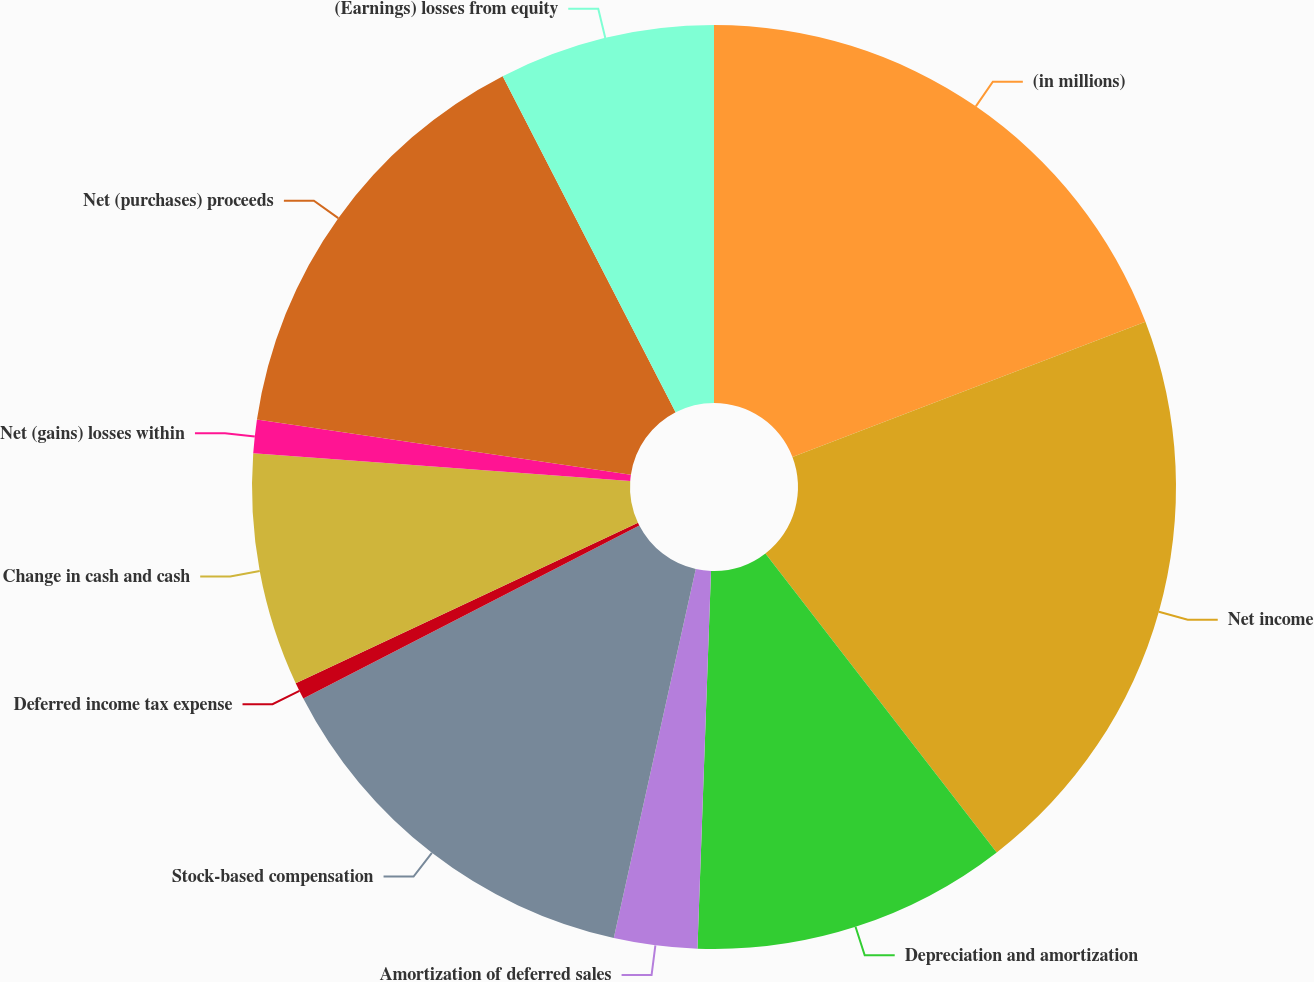Convert chart. <chart><loc_0><loc_0><loc_500><loc_500><pie_chart><fcel>(in millions)<fcel>Net income<fcel>Depreciation and amortization<fcel>Amortization of deferred sales<fcel>Stock-based compensation<fcel>Deferred income tax expense<fcel>Change in cash and cash<fcel>Net (gains) losses within<fcel>Net (purchases) proceeds<fcel>(Earnings) losses from equity<nl><fcel>19.18%<fcel>20.34%<fcel>11.05%<fcel>2.91%<fcel>13.95%<fcel>0.59%<fcel>8.14%<fcel>1.17%<fcel>15.11%<fcel>7.56%<nl></chart> 